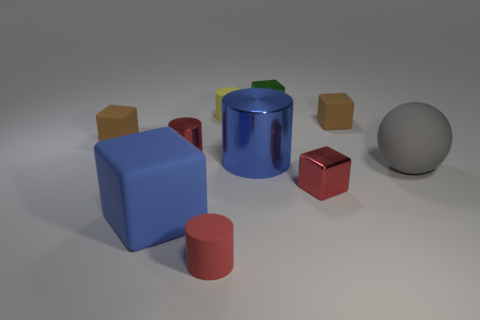Subtract all purple cubes. Subtract all gray cylinders. How many cubes are left? 5 Subtract all cylinders. How many objects are left? 6 Add 10 large metallic blocks. How many large metallic blocks exist? 10 Subtract 0 cyan balls. How many objects are left? 10 Subtract all brown matte blocks. Subtract all blue metal objects. How many objects are left? 7 Add 3 large blue cylinders. How many large blue cylinders are left? 4 